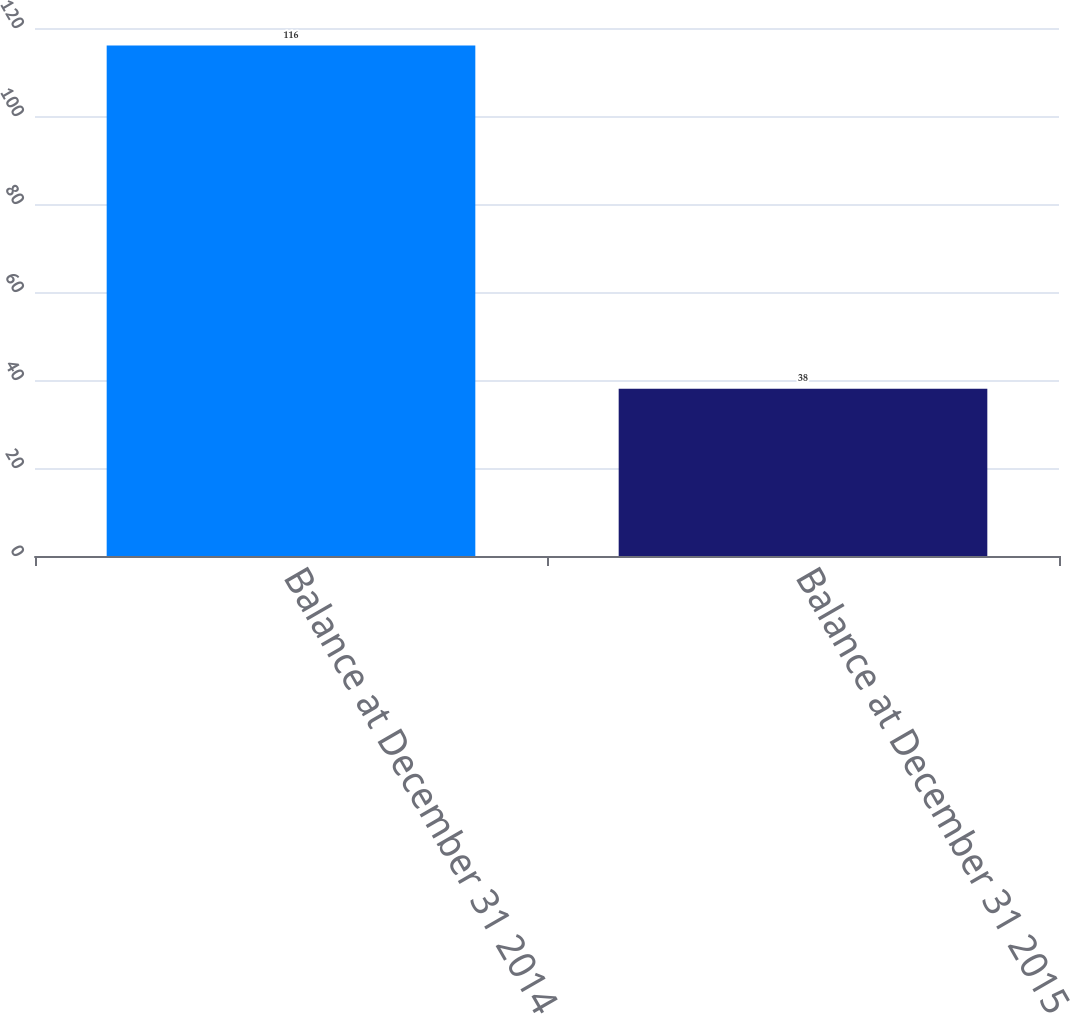Convert chart. <chart><loc_0><loc_0><loc_500><loc_500><bar_chart><fcel>Balance at December 31 2014<fcel>Balance at December 31 2015<nl><fcel>116<fcel>38<nl></chart> 